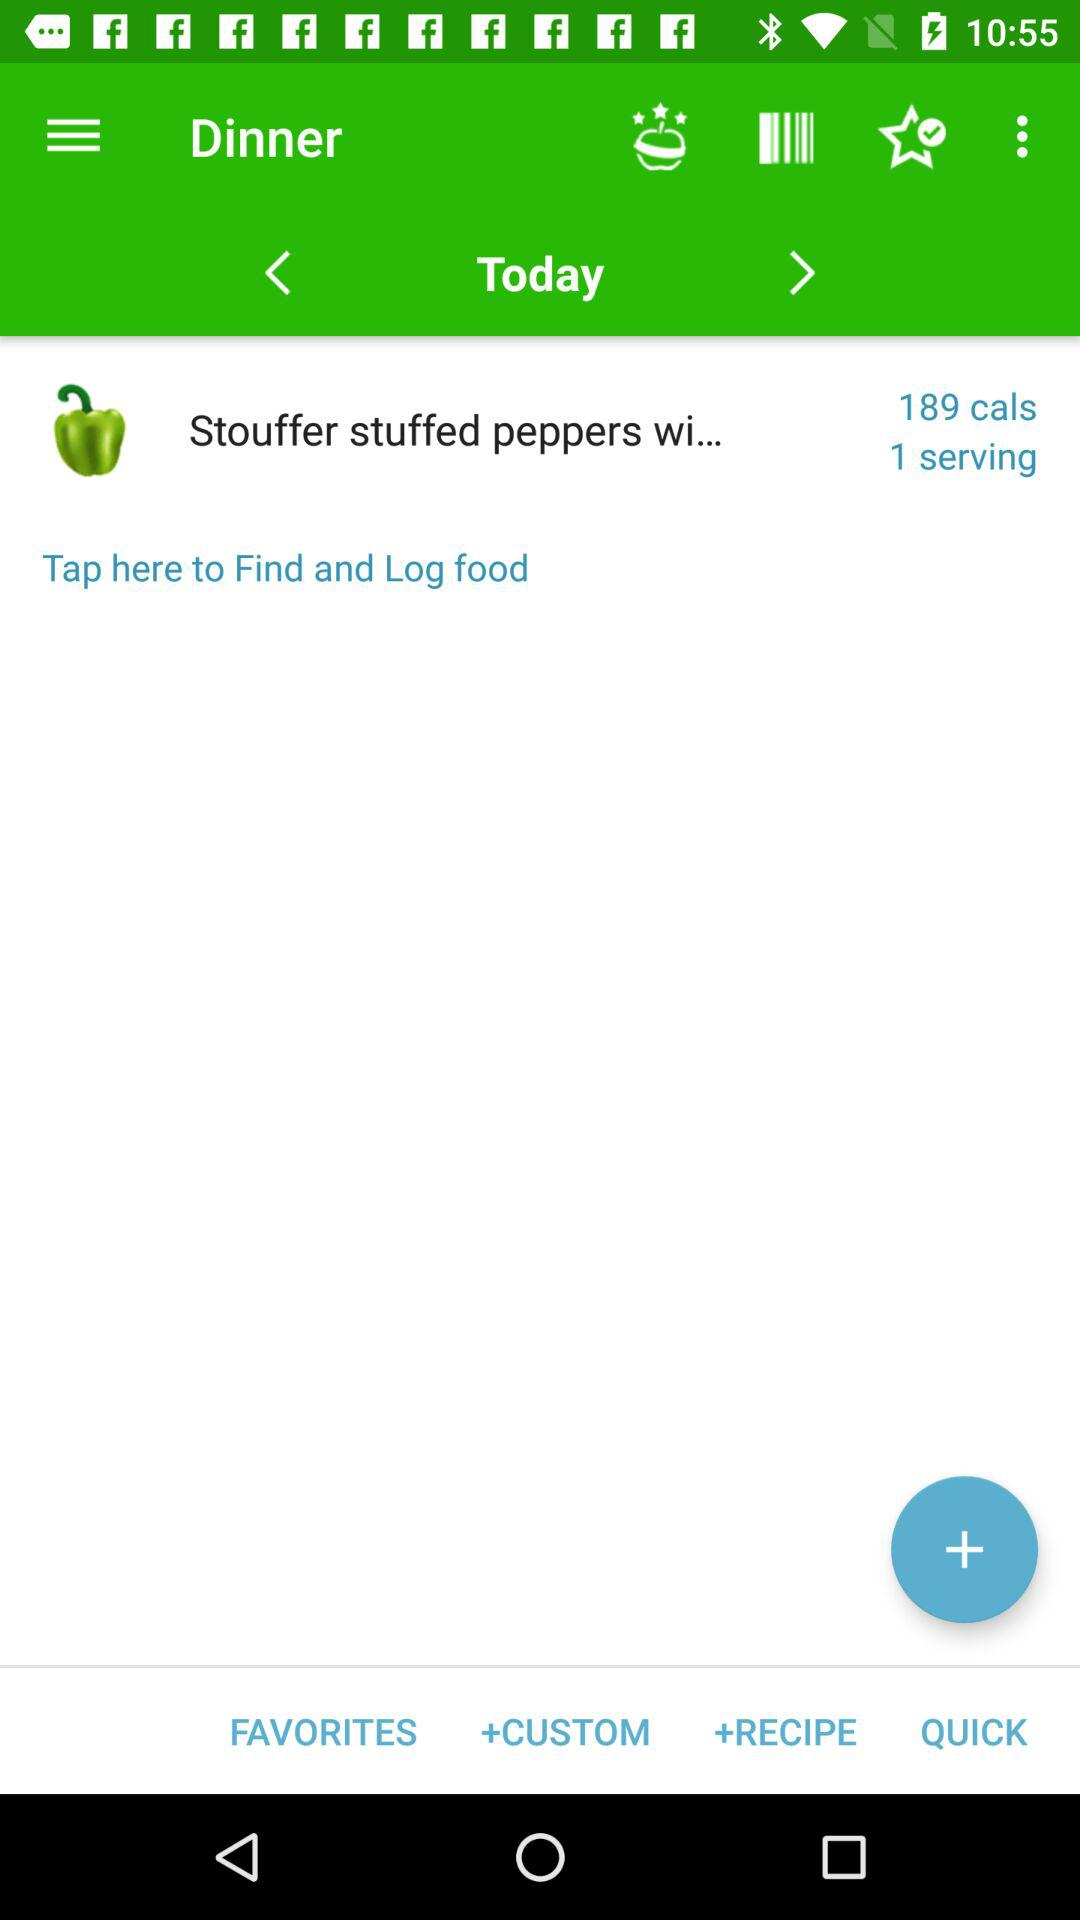How many calories are in the meal?
Answer the question using a single word or phrase. 189 